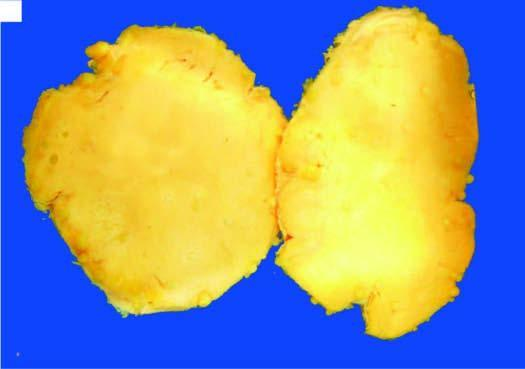what is soft, lobulated, yellowish and greasy?
Answer the question using a single word or phrase. Cut surface of the tumour 